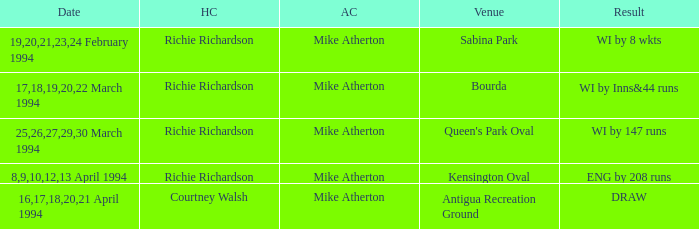Which Home captain has Date of 25,26,27,29,30 march 1994? Richie Richardson. 